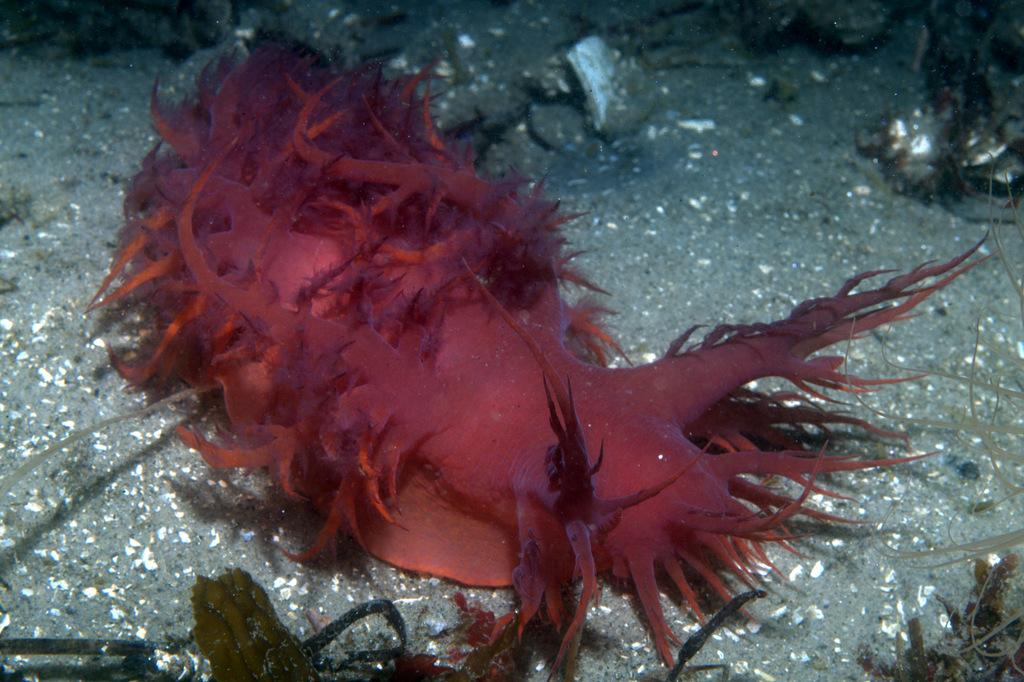What type of creature is the main subject of the image? There is a sea slug in the image. Can you describe the setting of the image? The image depicts an underwater environment. What is the title of the book that the sea slug is reading in the image? There is no book or reading activity depicted in the image, as it features a sea slug in an underwater environment. 